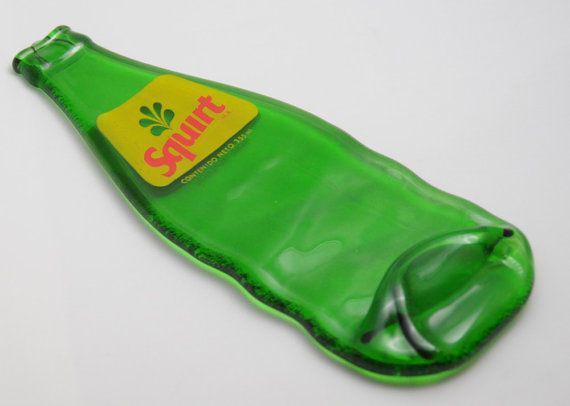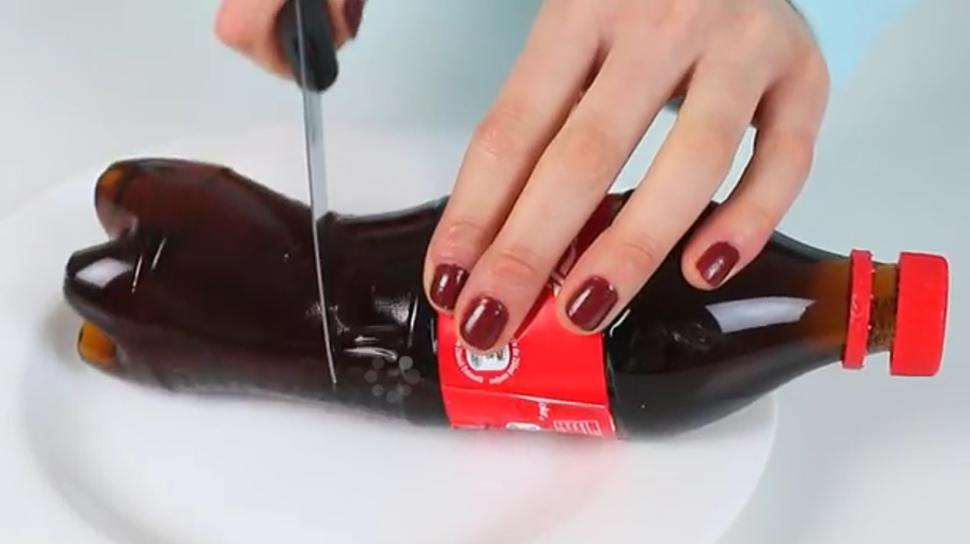The first image is the image on the left, the second image is the image on the right. Considering the images on both sides, is "A person is holding a knife to a bottle in the image on the right." valid? Answer yes or no. Yes. The first image is the image on the left, the second image is the image on the right. Examine the images to the left and right. Is the description "The right image shows a knife slicing through a bottle on its side, and the left image includes an upright bottle of cola." accurate? Answer yes or no. No. 